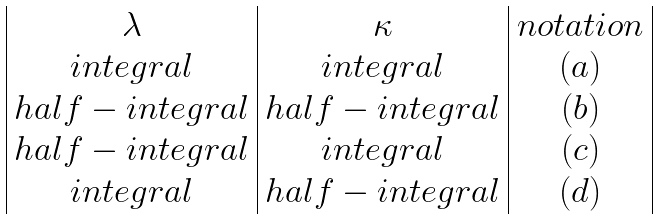Convert formula to latex. <formula><loc_0><loc_0><loc_500><loc_500>\begin{array} { | c | c | c | } \lambda & \kappa & n o t a t i o n \\ i n t e g r a l & i n t e g r a l & ( a ) \\ h a l f - i n t e g r a l & h a l f - i n t e g r a l & ( b ) \\ h a l f - i n t e g r a l & i n t e g r a l & ( c ) \\ i n t e g r a l & h a l f - i n t e g r a l & ( d ) \\ \end{array}</formula> 